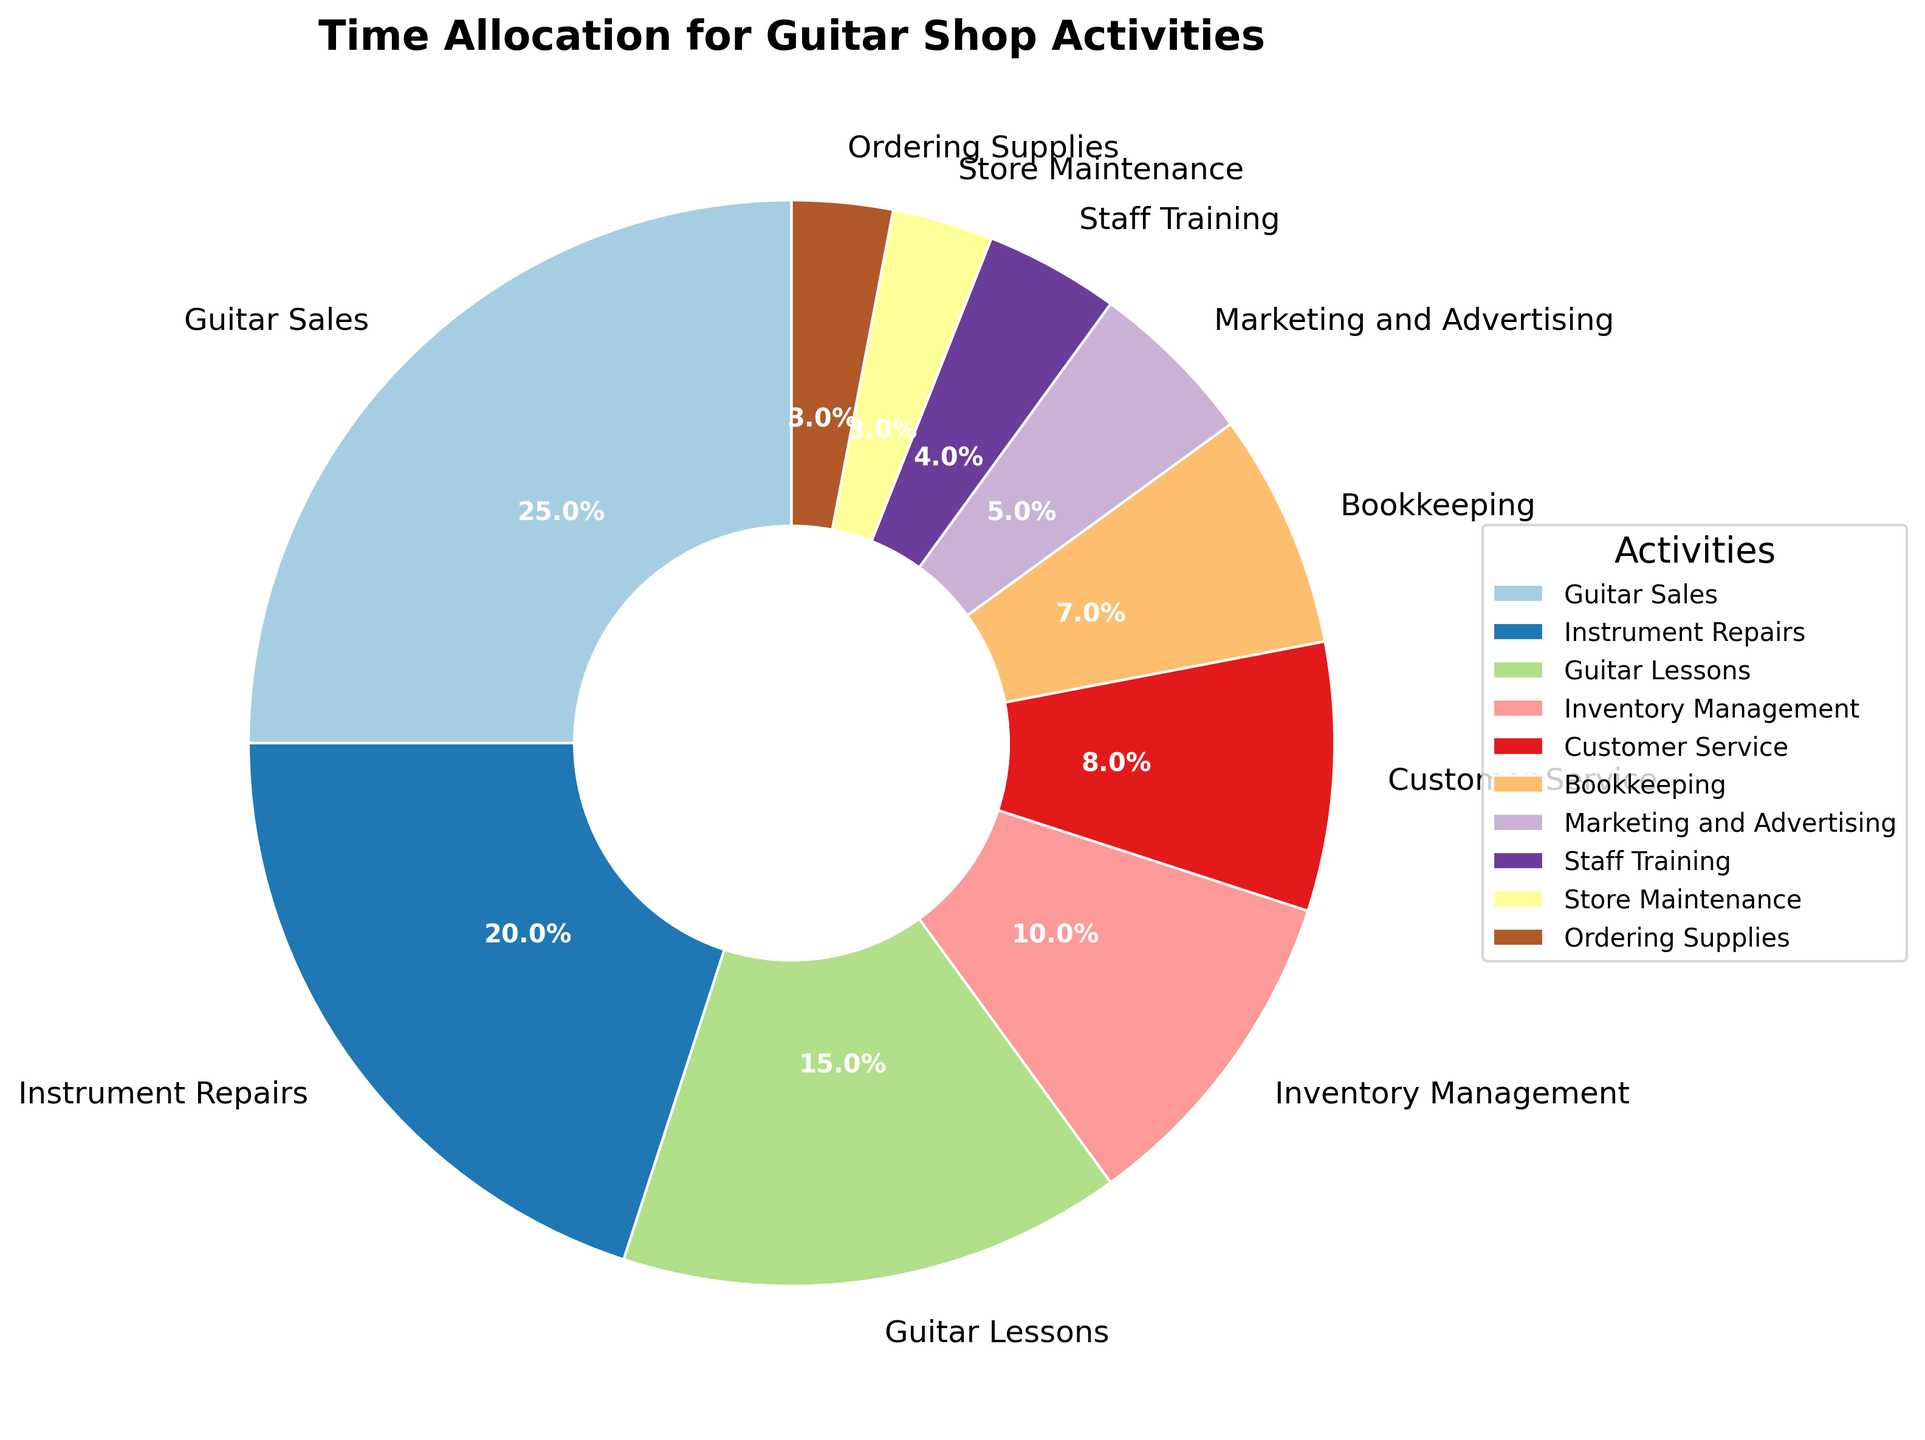Which activity takes up the most hours per week? Guitar Sales account for the most hours as per the largest wedge in the pie chart marked with 25 hours.
Answer: Guitar Sales Which two activities combined take up the same amount of time as Instrument Repairs? Guitar Lessons (15 hours) and Customer Service (8 hours) combined make up 23 hours, which is closest but less than Instrument Repairs (20 hours). Instead, combining Inventory Management (10 hours) and Customer Service (8 hours) makes 18 hours, so combining Customer Service (8 hours) and Bookkeeping (7 hours) make 15 hours + Marketing and Advertising (5 hours) totals 20 hours.
Answer: Guitar Lessons and Inventory Management How many more hours are spent on Sales compared to Customer Service? Guitar Sales take 25 hours while Customer Service takes 8 hours; the difference is 25 - 8 = 17 hours.
Answer: 17 hours What percentage of the week is spent on Store Maintenance and Ordering Supplies together? Store Maintenance takes 3 hours, and Ordering Supplies also takes 3 hours. Together, they take up 3 + 3 = 6 hours. To find the percentage: (6/100) * 100% = 6%.
Answer: 6% Which activity takes up less than half the time spent on Marketing and Advertising? Store Maintenance and Ordering Supplies both take 3 hours each, which is less than half of Marketing and Advertising’s 5 hours (half of 5 is 2.5).
Answer: Store Maintenance and Ordering Supplies If you combine the hours for Staff Training and Bookkeeping, is it more or less than Guitar Lessons? Staff Training takes 4 hours and Bookkeeping takes 7 hours. Combined they take 4 + 7 = 11 hours, which is less than Guitar Lessons' 15 hours.
Answer: Less Which activities take up more than 10% of the total time each week? Guitar Sales (25%) and Instrument Repairs (20%) each occupy more than 10% of the total time because their wedges are clearly marked with those percentages, each more than 10%.
Answer: Guitar Sales and Instrument Repairs Which two activities together take as much time as Bookkeeping? Bookkeeping takes 7 hours. Store Maintenance and Ordering Supplies both individually take 3 hours each; together they take 3 + 3 = 6 hours, which is less than 7. Instead, combining Staff Training (4 hours) and Store Maintenance (3 hours) gives us 4 + 3 = 7 hours, which exactly equals Bookkeeping's time.
Answer: Staff Training and Store Maintenance 